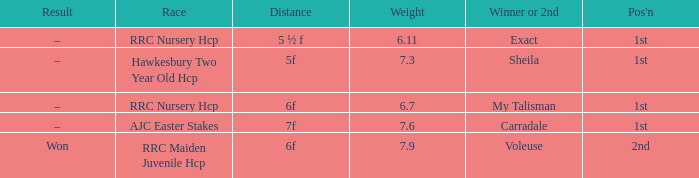What is the weight number when the distance was 5 ½ f? 1.0. Would you mind parsing the complete table? {'header': ['Result', 'Race', 'Distance', 'Weight', 'Winner or 2nd', "Pos'n"], 'rows': [['–', 'RRC Nursery Hcp', '5 ½ f', '6.11', 'Exact', '1st'], ['–', 'Hawkesbury Two Year Old Hcp', '5f', '7.3', 'Sheila', '1st'], ['–', 'RRC Nursery Hcp', '6f', '6.7', 'My Talisman', '1st'], ['–', 'AJC Easter Stakes', '7f', '7.6', 'Carradale', '1st'], ['Won', 'RRC Maiden Juvenile Hcp', '6f', '7.9', 'Voleuse', '2nd']]} 